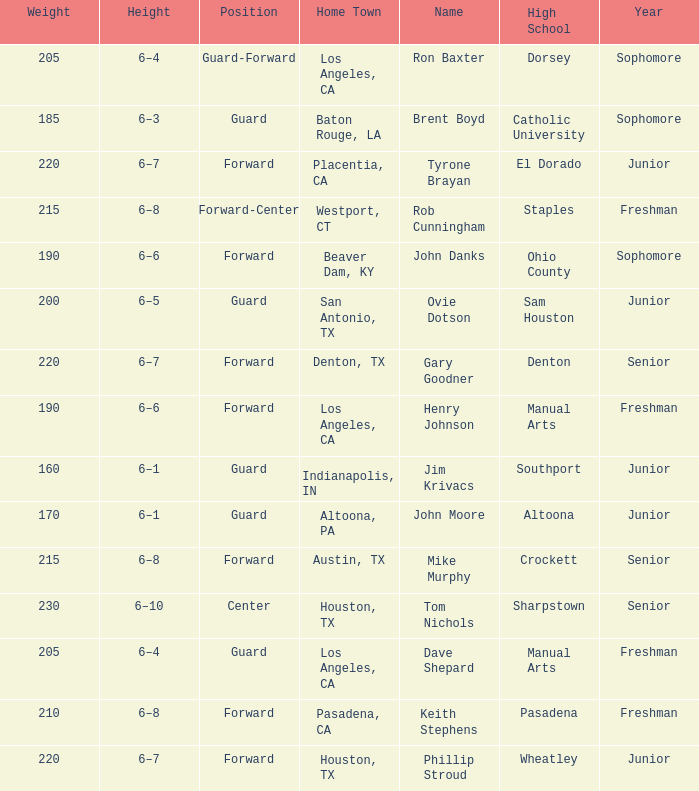What is the Name with a Year with freshman, and a Home Town with los angeles, ca, and a Height of 6–4? Dave Shepard. 